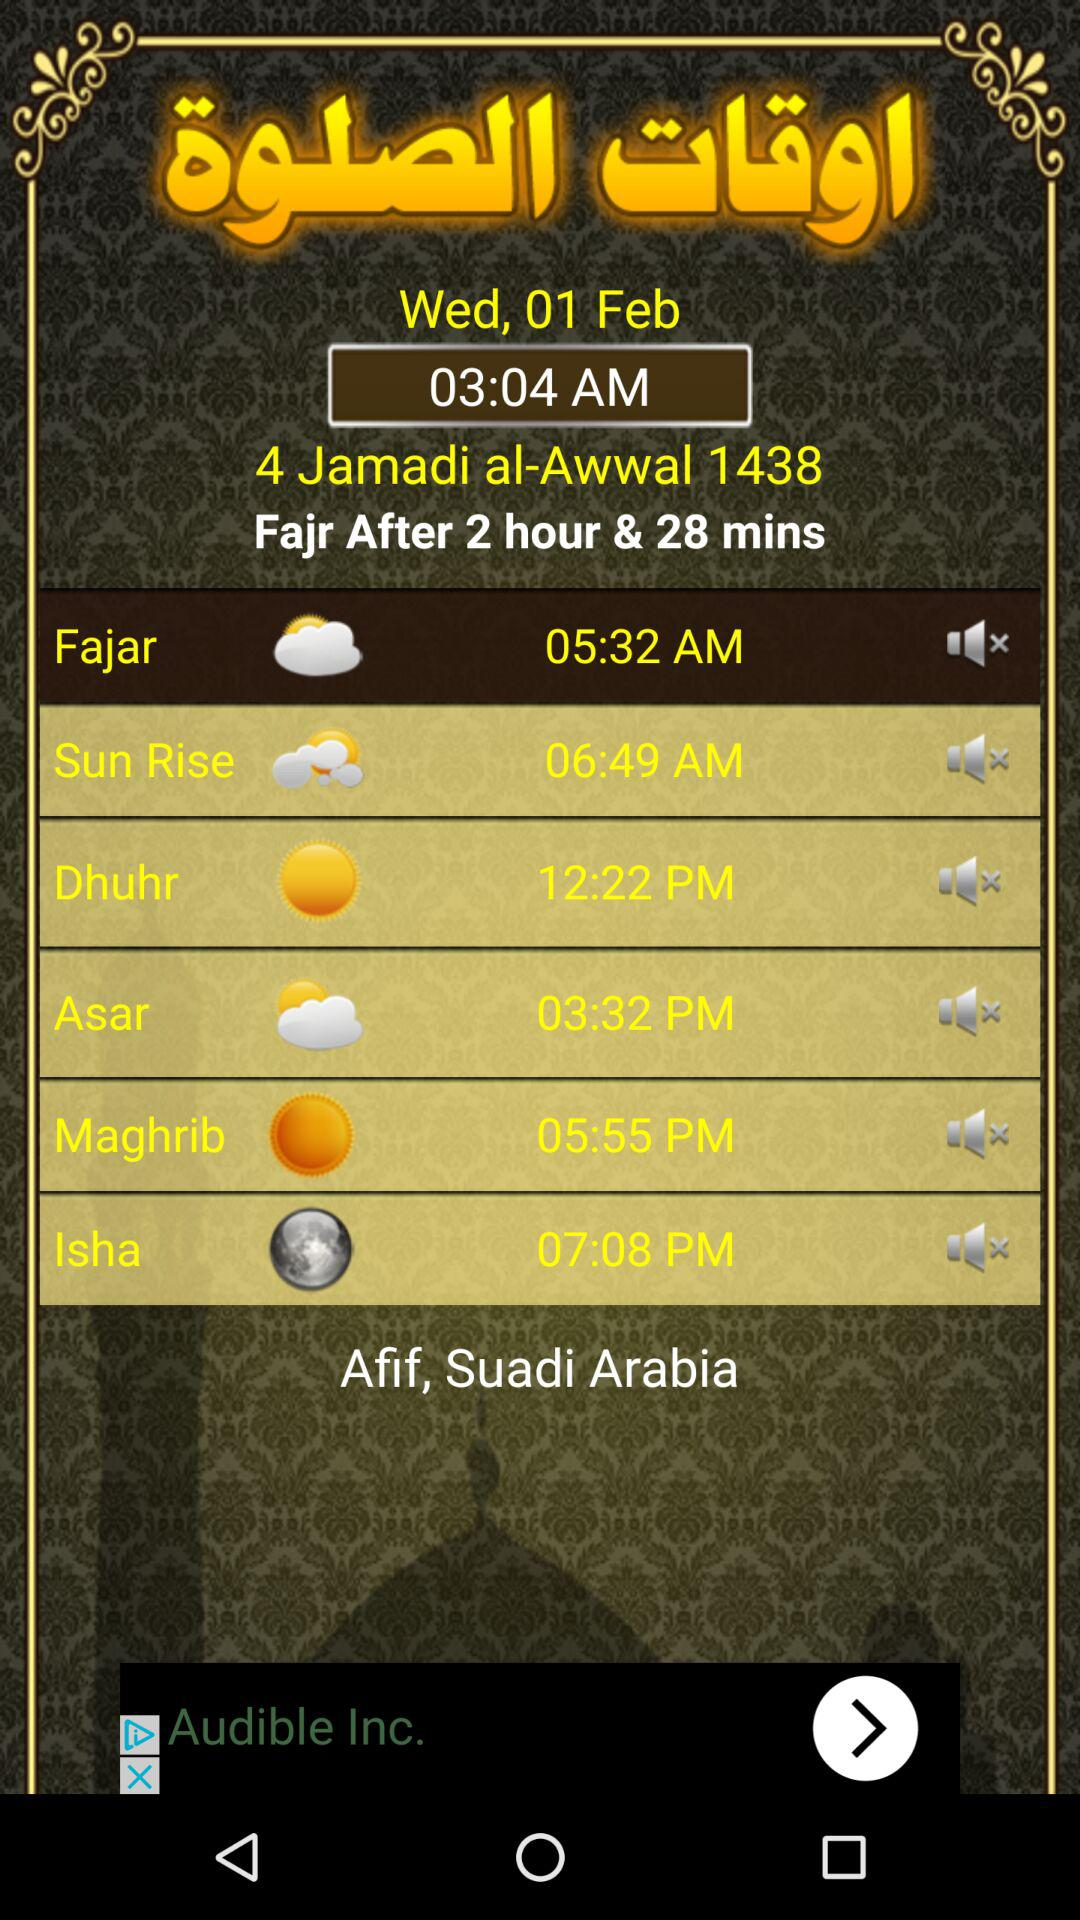What is the mentioned date? The mentioned date is Wednesday, February 1. 